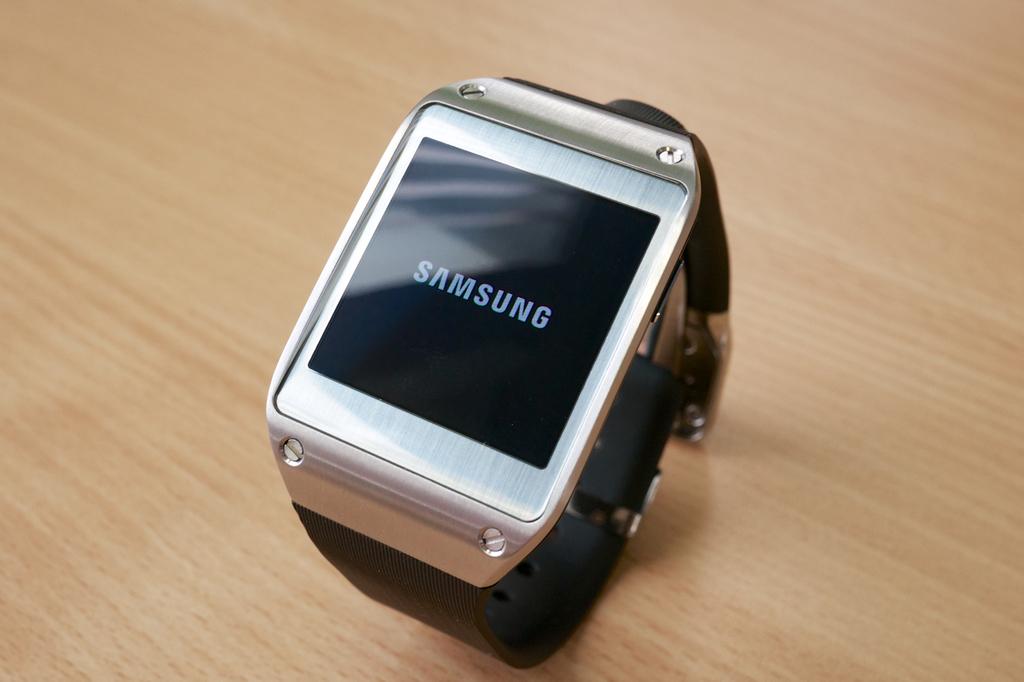What company made this watch?
Ensure brevity in your answer.  Samsung. What color is the text of the company name?
Make the answer very short. White. 